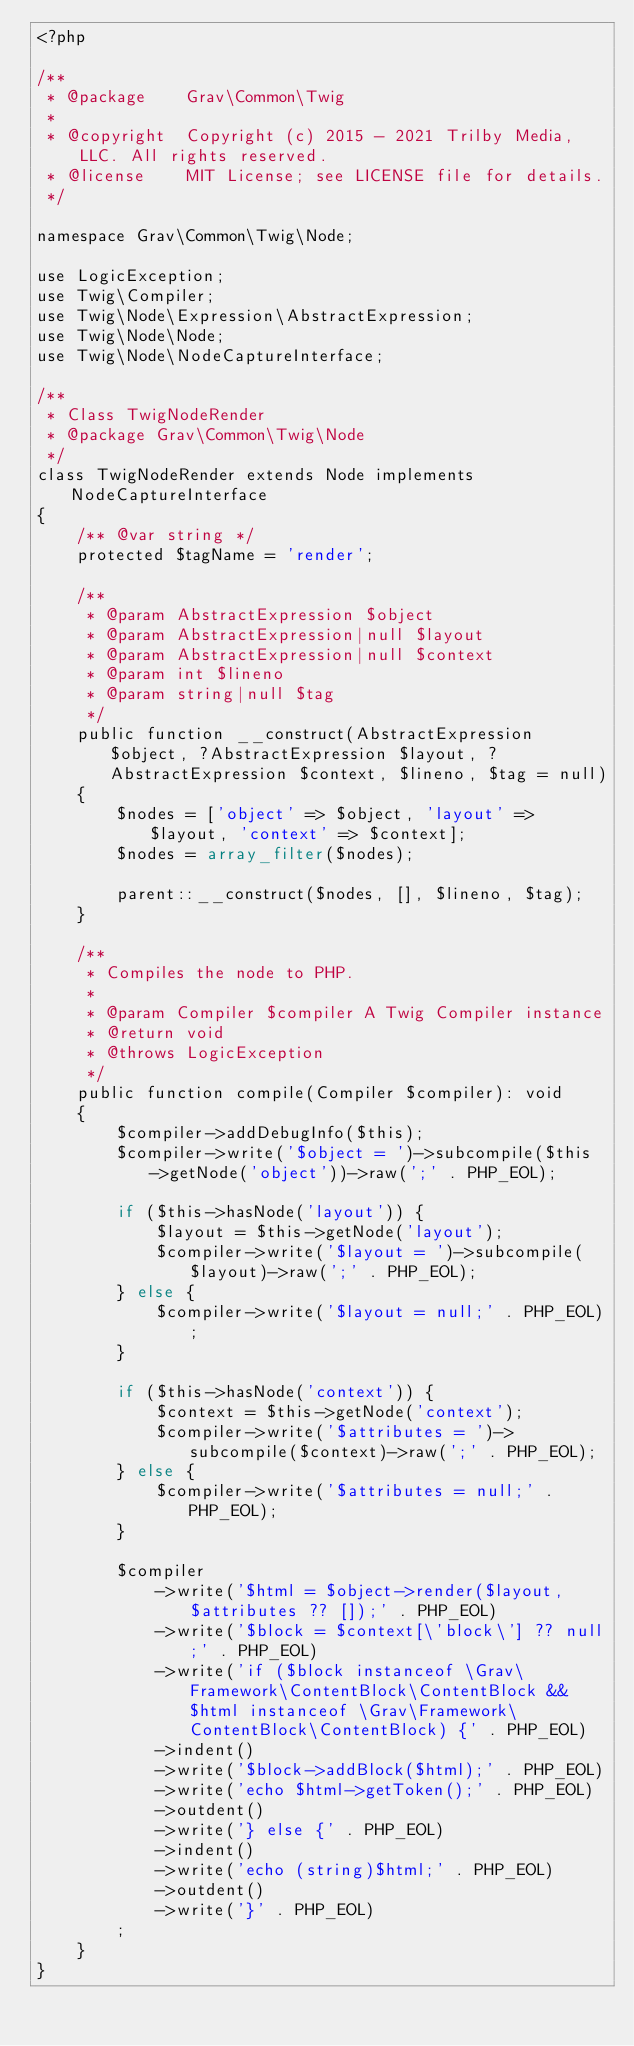<code> <loc_0><loc_0><loc_500><loc_500><_PHP_><?php

/**
 * @package    Grav\Common\Twig
 *
 * @copyright  Copyright (c) 2015 - 2021 Trilby Media, LLC. All rights reserved.
 * @license    MIT License; see LICENSE file for details.
 */

namespace Grav\Common\Twig\Node;

use LogicException;
use Twig\Compiler;
use Twig\Node\Expression\AbstractExpression;
use Twig\Node\Node;
use Twig\Node\NodeCaptureInterface;

/**
 * Class TwigNodeRender
 * @package Grav\Common\Twig\Node
 */
class TwigNodeRender extends Node implements NodeCaptureInterface
{
    /** @var string */
    protected $tagName = 'render';

    /**
     * @param AbstractExpression $object
     * @param AbstractExpression|null $layout
     * @param AbstractExpression|null $context
     * @param int $lineno
     * @param string|null $tag
     */
    public function __construct(AbstractExpression $object, ?AbstractExpression $layout, ?AbstractExpression $context, $lineno, $tag = null)
    {
        $nodes = ['object' => $object, 'layout' => $layout, 'context' => $context];
        $nodes = array_filter($nodes);

        parent::__construct($nodes, [], $lineno, $tag);
    }

    /**
     * Compiles the node to PHP.
     *
     * @param Compiler $compiler A Twig Compiler instance
     * @return void
     * @throws LogicException
     */
    public function compile(Compiler $compiler): void
    {
        $compiler->addDebugInfo($this);
        $compiler->write('$object = ')->subcompile($this->getNode('object'))->raw(';' . PHP_EOL);

        if ($this->hasNode('layout')) {
            $layout = $this->getNode('layout');
            $compiler->write('$layout = ')->subcompile($layout)->raw(';' . PHP_EOL);
        } else {
            $compiler->write('$layout = null;' . PHP_EOL);
        }

        if ($this->hasNode('context')) {
            $context = $this->getNode('context');
            $compiler->write('$attributes = ')->subcompile($context)->raw(';' . PHP_EOL);
        } else {
            $compiler->write('$attributes = null;' . PHP_EOL);
        }

        $compiler
            ->write('$html = $object->render($layout, $attributes ?? []);' . PHP_EOL)
            ->write('$block = $context[\'block\'] ?? null;' . PHP_EOL)
            ->write('if ($block instanceof \Grav\Framework\ContentBlock\ContentBlock && $html instanceof \Grav\Framework\ContentBlock\ContentBlock) {' . PHP_EOL)
            ->indent()
            ->write('$block->addBlock($html);' . PHP_EOL)
            ->write('echo $html->getToken();' . PHP_EOL)
            ->outdent()
            ->write('} else {' . PHP_EOL)
            ->indent()
            ->write('echo (string)$html;' . PHP_EOL)
            ->outdent()
            ->write('}' . PHP_EOL)
        ;
    }
}
</code> 